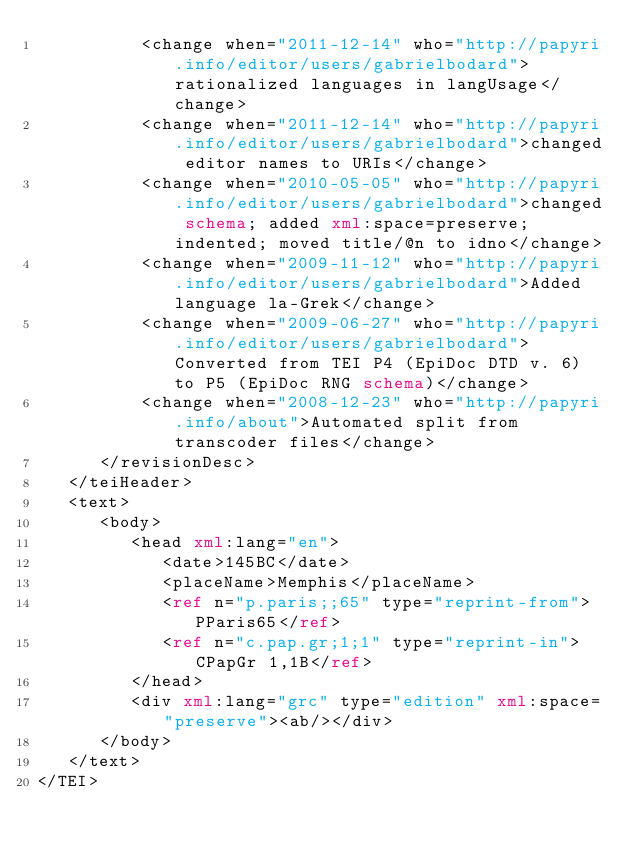<code> <loc_0><loc_0><loc_500><loc_500><_XML_>          <change when="2011-12-14" who="http://papyri.info/editor/users/gabrielbodard">rationalized languages in langUsage</change>
          <change when="2011-12-14" who="http://papyri.info/editor/users/gabrielbodard">changed editor names to URIs</change>
          <change when="2010-05-05" who="http://papyri.info/editor/users/gabrielbodard">changed schema; added xml:space=preserve; indented; moved title/@n to idno</change>
          <change when="2009-11-12" who="http://papyri.info/editor/users/gabrielbodard">Added language la-Grek</change>
          <change when="2009-06-27" who="http://papyri.info/editor/users/gabrielbodard">Converted from TEI P4 (EpiDoc DTD v. 6) to P5 (EpiDoc RNG schema)</change>
          <change when="2008-12-23" who="http://papyri.info/about">Automated split from transcoder files</change>
      </revisionDesc>
   </teiHeader>
   <text>
      <body>
         <head xml:lang="en">
            <date>145BC</date>
            <placeName>Memphis</placeName>
            <ref n="p.paris;;65" type="reprint-from">PParis65</ref>
            <ref n="c.pap.gr;1;1" type="reprint-in">CPapGr 1,1B</ref>
         </head>
         <div xml:lang="grc" type="edition" xml:space="preserve"><ab/></div>
      </body>
   </text>
</TEI>
</code> 